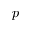<formula> <loc_0><loc_0><loc_500><loc_500>p</formula> 